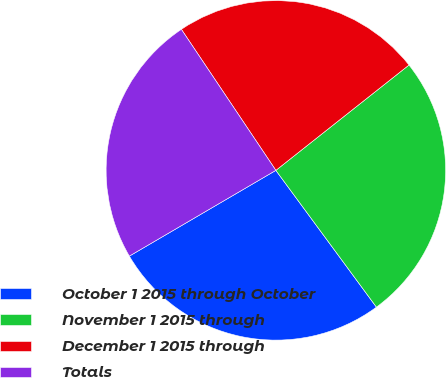Convert chart to OTSL. <chart><loc_0><loc_0><loc_500><loc_500><pie_chart><fcel>October 1 2015 through October<fcel>November 1 2015 through<fcel>December 1 2015 through<fcel>Totals<nl><fcel>26.66%<fcel>25.56%<fcel>23.74%<fcel>24.03%<nl></chart> 